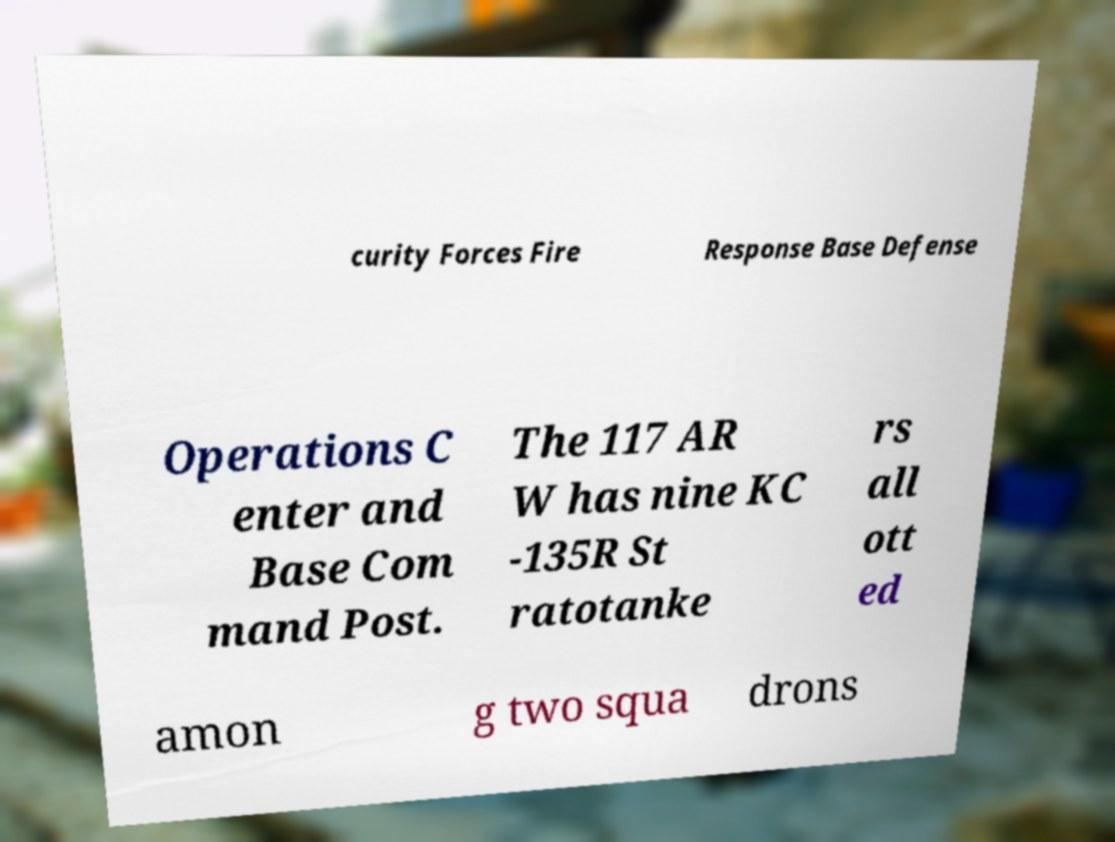Could you extract and type out the text from this image? curity Forces Fire Response Base Defense Operations C enter and Base Com mand Post. The 117 AR W has nine KC -135R St ratotanke rs all ott ed amon g two squa drons 